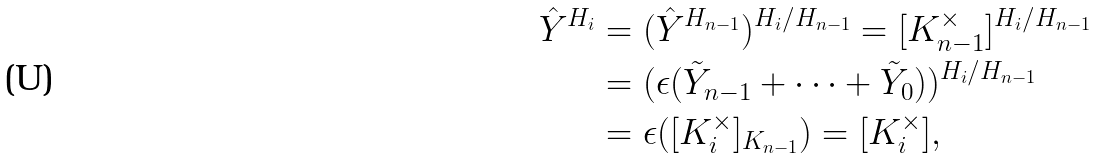Convert formula to latex. <formula><loc_0><loc_0><loc_500><loc_500>\hat { Y } ^ { H _ { i } } & = ( \hat { Y } ^ { H _ { n - 1 } } ) ^ { H _ { i } / H _ { n - 1 } } = [ K _ { n - 1 } ^ { \times } ] ^ { H _ { i } / H _ { n - 1 } } \\ & = ( \epsilon ( \tilde { Y } _ { n - 1 } + \cdots + \tilde { Y } _ { 0 } ) ) ^ { H _ { i } / H _ { n - 1 } } \\ & = \epsilon ( [ K _ { i } ^ { \times } ] _ { K _ { n - 1 } } ) = [ K _ { i } ^ { \times } ] ,</formula> 